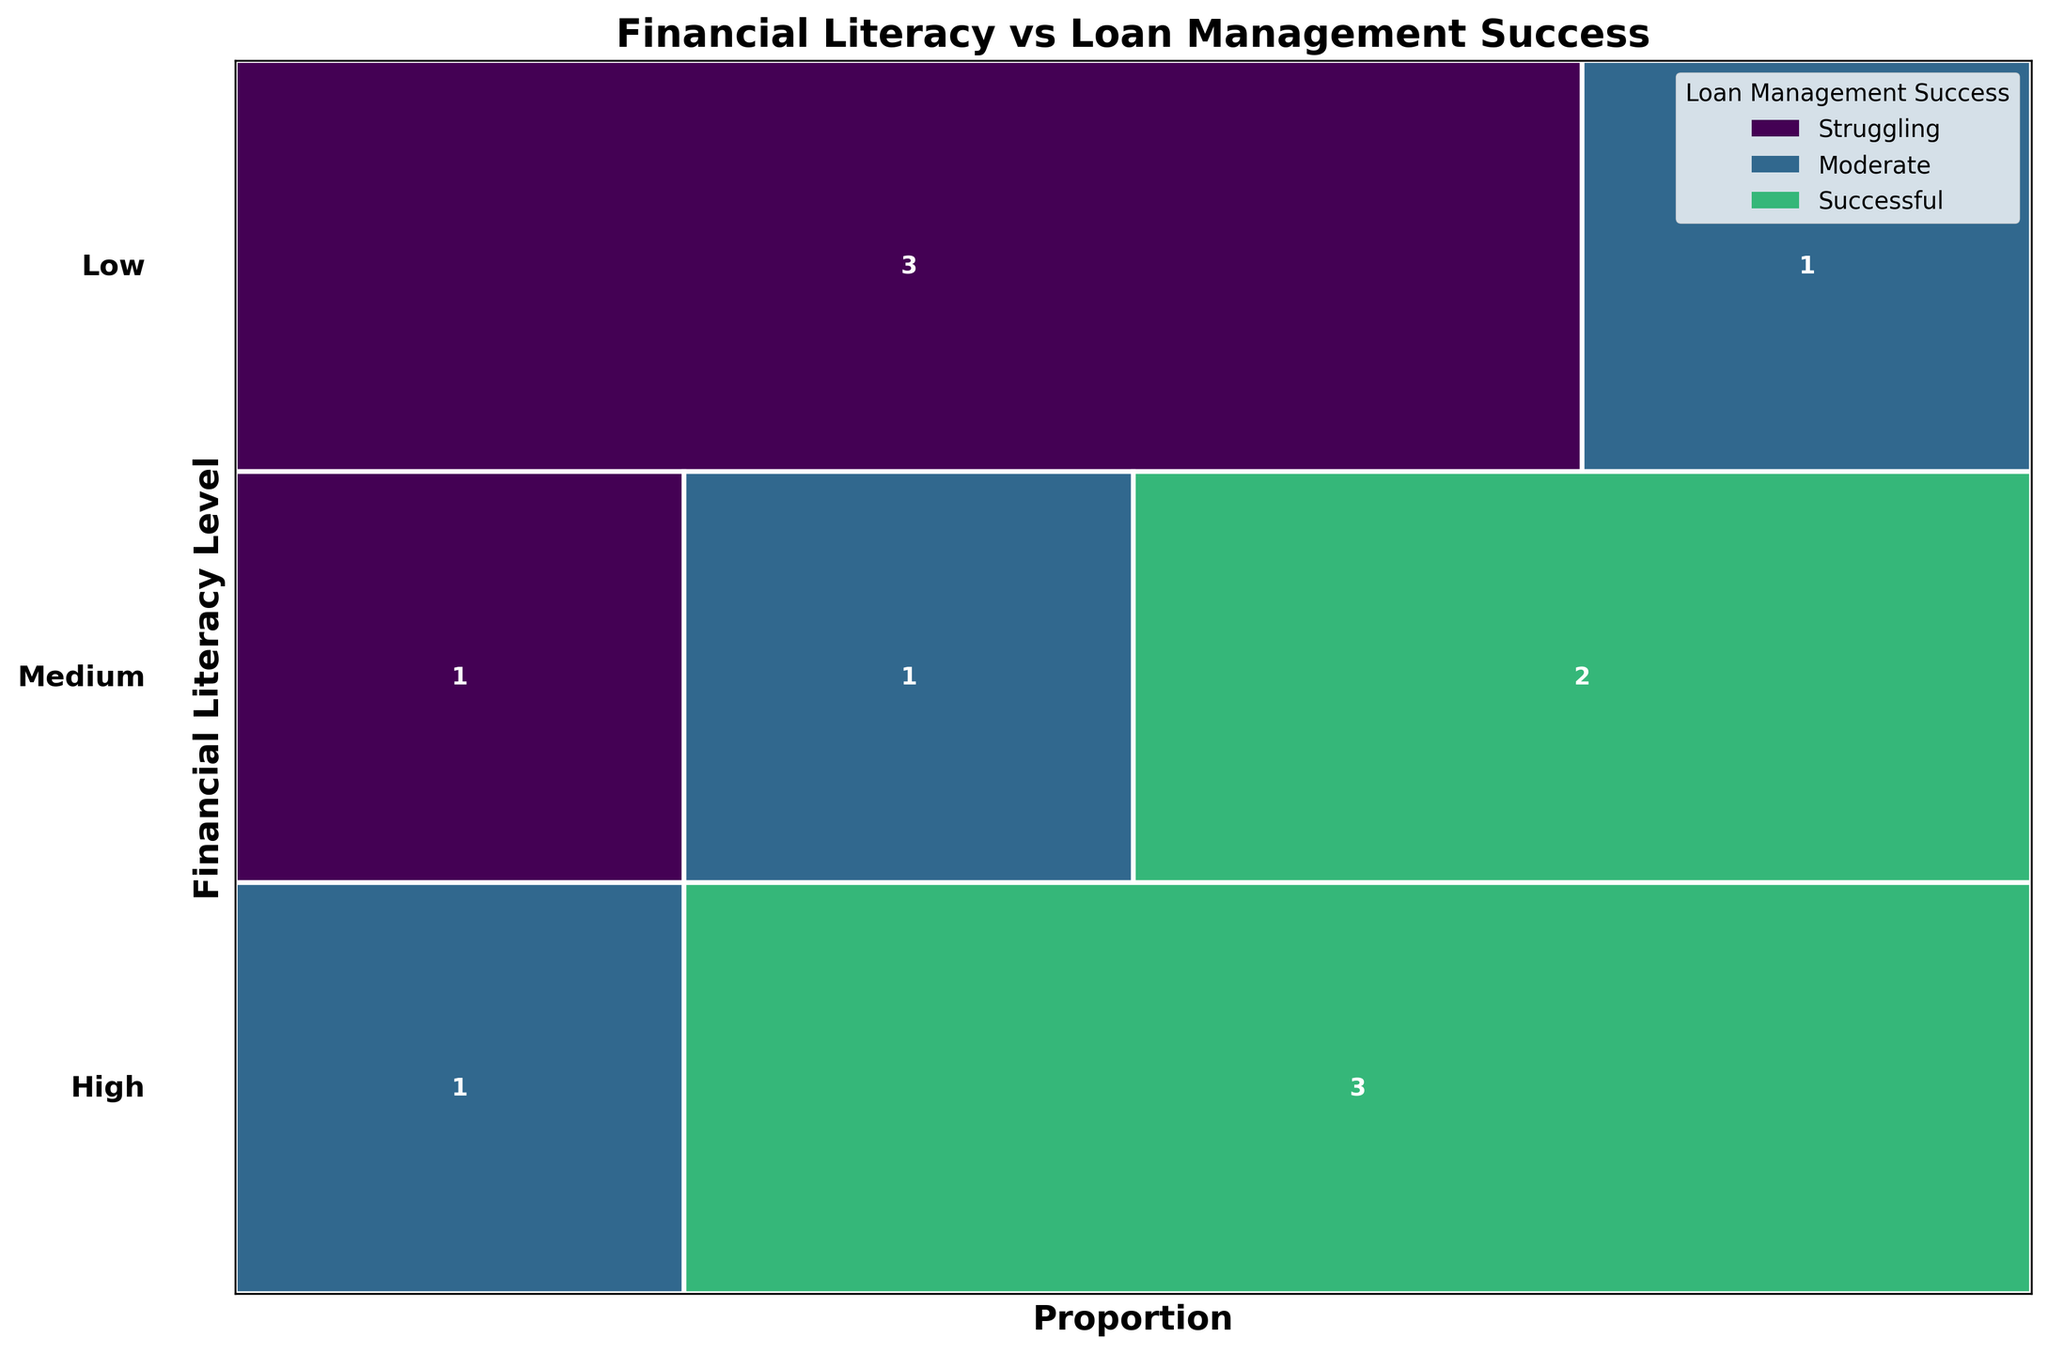What is the title of the figure? The title is usually presented at the top of the figure to summarize its content. By looking there, you can see the title clearly.
Answer: Financial Literacy vs Loan Management Success How many literacy levels are presented in the plot? The different literacy levels are typically listed along the y-axis. By counting them, we can determine the number of literacy levels displayed.
Answer: Three Which financial literacy level has the highest number of businesses struggling with loan management? By observing the rectangles corresponding to the 'Struggling' category within each literacy level, we can determine which literacy level has the largest rectangle.
Answer: Low What proportion of medium financial literacy businesses are successful in loan management? To find this, we locate the 'Medium' financial literacy row and observe the proportion of the rectangles in the 'Successful' category. It helps to check the proportion directly from the visual representation.
Answer: Approximately one-third Is there any financial literacy level where businesses have equal proportions in all loan management categories? We need to look at each financial literacy level and compare the sizes of the rectangles representing 'Struggling', 'Moderate', and 'Successful'. Equality in proportions would mean similar sized rectangles.
Answer: No Between medium and high literacy levels, which has a higher proportion of businesses in the 'Moderate' loan management category? By comparing the proportions of the 'Moderate' rectangles for 'Medium' and 'High' literacy levels, we can see which proportion is larger by observing their width.
Answer: High What is the total number of businesses with high financial literacy in the dataset? From the figure, we look at the total height of the 'High' literacy level. The number inside the rectangles for 'Struggling', 'Moderate', and 'Successful' can be added up to get the total.
Answer: 4 How does the proportion of successful businesses compare between low and high financial literacy levels? By comparing the size of the 'Successful' rectangles for both 'Low' and 'High' literacy levels, we can assess which one is proportionally larger.
Answer: Higher in High literacy level For businesses with a low financial literacy level, is the proportion of those moderately successful greater than those struggling? We need to visually compare the width of the 'Moderate' rectangle to the 'Struggling' rectangle within the 'Low' financial literacy level.
Answer: No Among the financial literacy levels, which one shows the greatest diversity in loan management success categories? The diversity can be inferred from the variety in rectangle sizes across the categories for each financial literacy level. By comparing all literacy levels, the one with varied rectangle sizes across all categories is identified.
Answer: Medium 